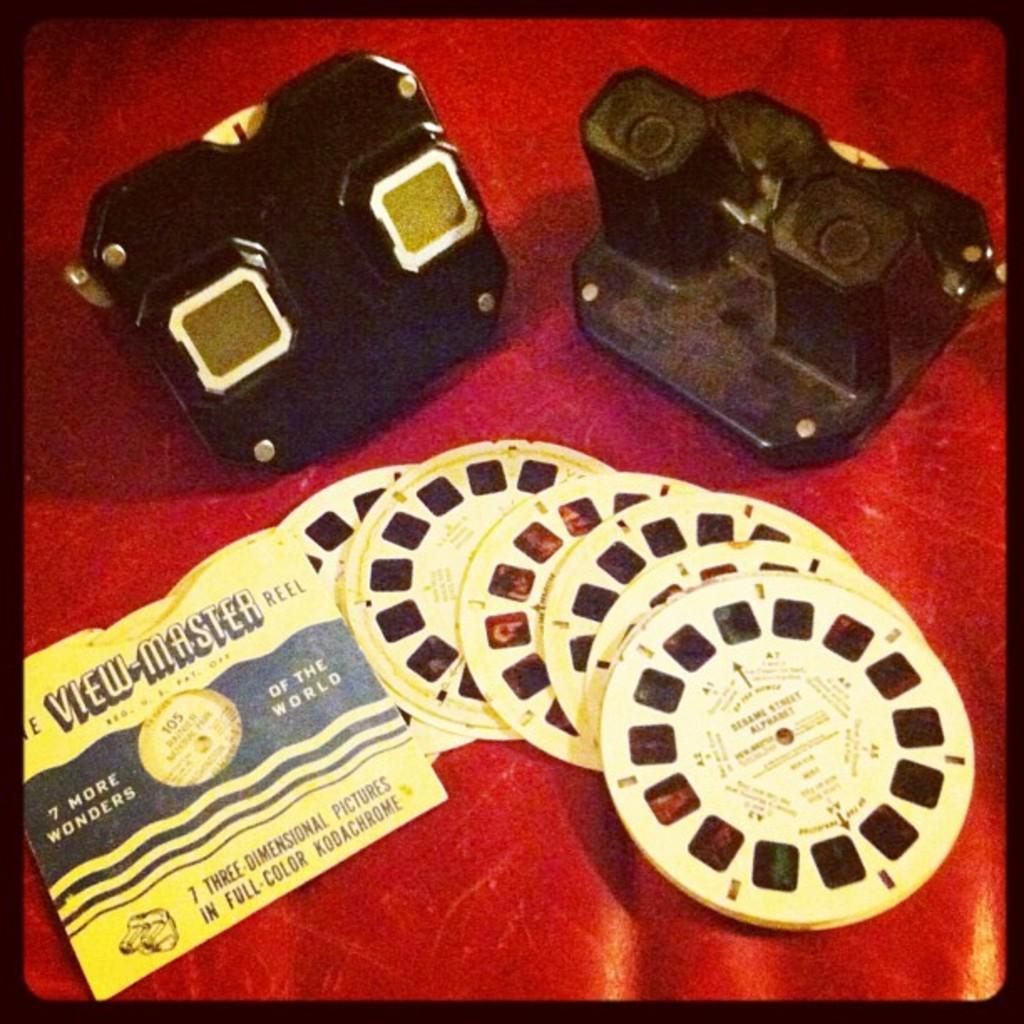In one or two sentences, can you explain what this image depicts? At the bottom there are camera reels in yellow color. On the left side there is a thing in black color. 